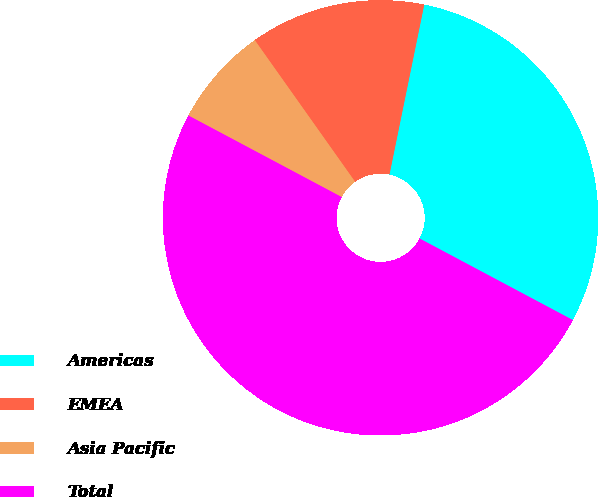<chart> <loc_0><loc_0><loc_500><loc_500><pie_chart><fcel>Americas<fcel>EMEA<fcel>Asia Pacific<fcel>Total<nl><fcel>29.57%<fcel>13.02%<fcel>7.41%<fcel>50.0%<nl></chart> 